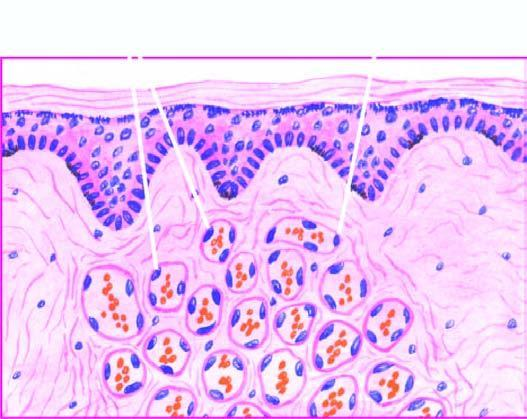what consists of scant connective tissue?
Answer the question using a single word or phrase. The intervening stroma 